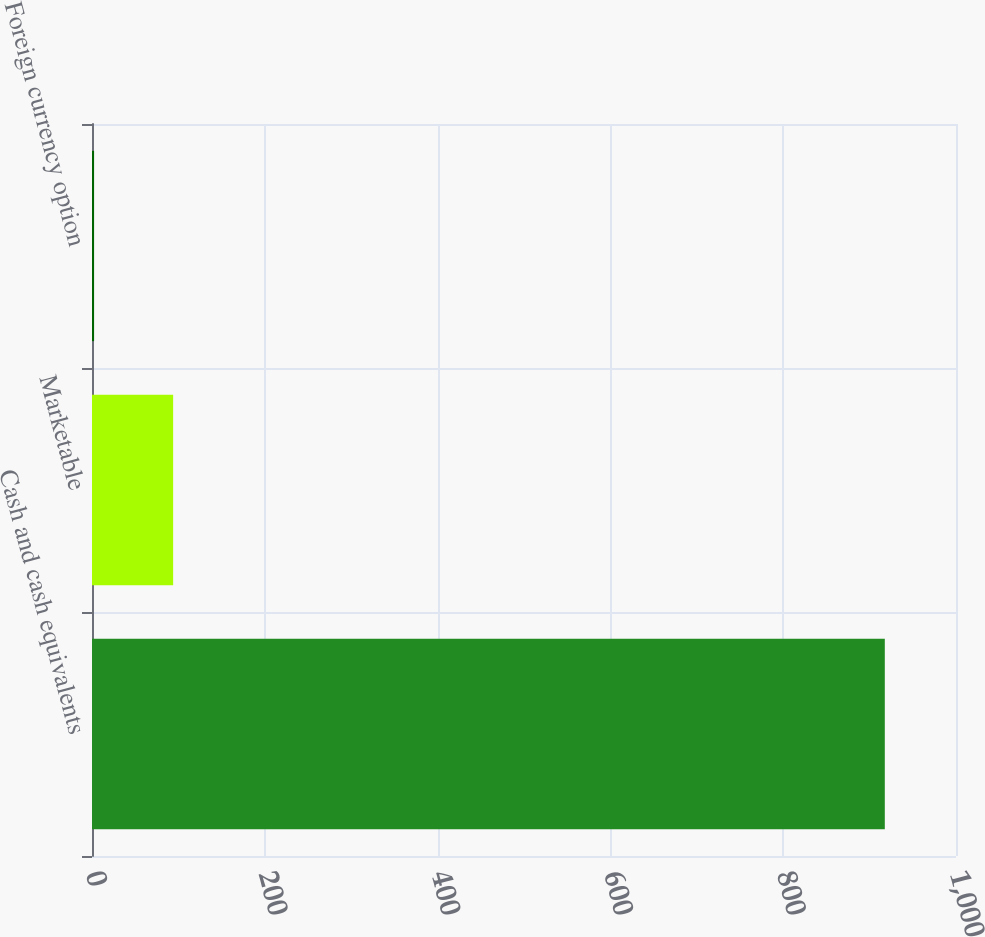Convert chart. <chart><loc_0><loc_0><loc_500><loc_500><bar_chart><fcel>Cash and cash equivalents<fcel>Marketable<fcel>Foreign currency option<nl><fcel>917.6<fcel>93.92<fcel>2.4<nl></chart> 